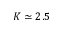Convert formula to latex. <formula><loc_0><loc_0><loc_500><loc_500>K \simeq 2 . 5</formula> 